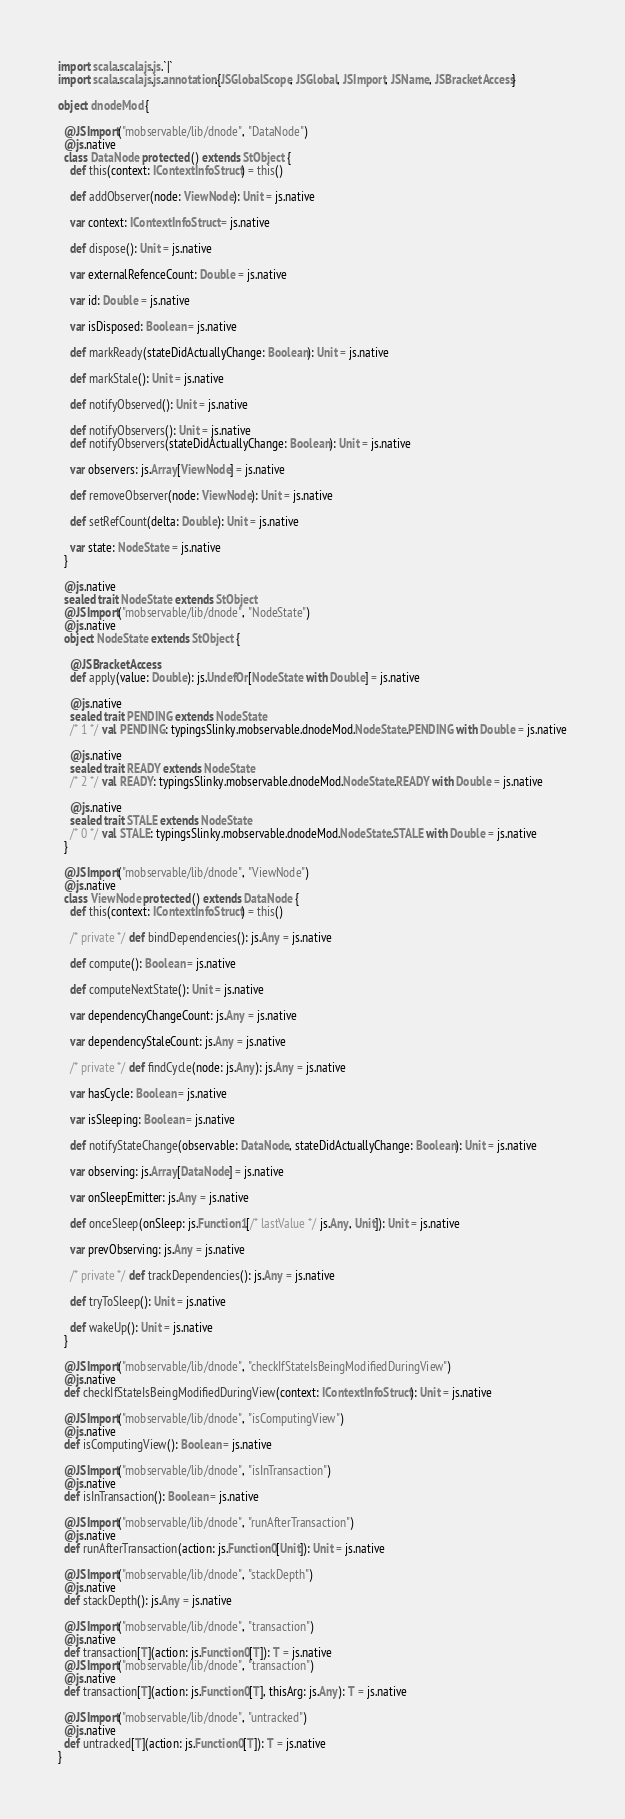Convert code to text. <code><loc_0><loc_0><loc_500><loc_500><_Scala_>import scala.scalajs.js.`|`
import scala.scalajs.js.annotation.{JSGlobalScope, JSGlobal, JSImport, JSName, JSBracketAccess}

object dnodeMod {
  
  @JSImport("mobservable/lib/dnode", "DataNode")
  @js.native
  class DataNode protected () extends StObject {
    def this(context: IContextInfoStruct) = this()
    
    def addObserver(node: ViewNode): Unit = js.native
    
    var context: IContextInfoStruct = js.native
    
    def dispose(): Unit = js.native
    
    var externalRefenceCount: Double = js.native
    
    var id: Double = js.native
    
    var isDisposed: Boolean = js.native
    
    def markReady(stateDidActuallyChange: Boolean): Unit = js.native
    
    def markStale(): Unit = js.native
    
    def notifyObserved(): Unit = js.native
    
    def notifyObservers(): Unit = js.native
    def notifyObservers(stateDidActuallyChange: Boolean): Unit = js.native
    
    var observers: js.Array[ViewNode] = js.native
    
    def removeObserver(node: ViewNode): Unit = js.native
    
    def setRefCount(delta: Double): Unit = js.native
    
    var state: NodeState = js.native
  }
  
  @js.native
  sealed trait NodeState extends StObject
  @JSImport("mobservable/lib/dnode", "NodeState")
  @js.native
  object NodeState extends StObject {
    
    @JSBracketAccess
    def apply(value: Double): js.UndefOr[NodeState with Double] = js.native
    
    @js.native
    sealed trait PENDING extends NodeState
    /* 1 */ val PENDING: typingsSlinky.mobservable.dnodeMod.NodeState.PENDING with Double = js.native
    
    @js.native
    sealed trait READY extends NodeState
    /* 2 */ val READY: typingsSlinky.mobservable.dnodeMod.NodeState.READY with Double = js.native
    
    @js.native
    sealed trait STALE extends NodeState
    /* 0 */ val STALE: typingsSlinky.mobservable.dnodeMod.NodeState.STALE with Double = js.native
  }
  
  @JSImport("mobservable/lib/dnode", "ViewNode")
  @js.native
  class ViewNode protected () extends DataNode {
    def this(context: IContextInfoStruct) = this()
    
    /* private */ def bindDependencies(): js.Any = js.native
    
    def compute(): Boolean = js.native
    
    def computeNextState(): Unit = js.native
    
    var dependencyChangeCount: js.Any = js.native
    
    var dependencyStaleCount: js.Any = js.native
    
    /* private */ def findCycle(node: js.Any): js.Any = js.native
    
    var hasCycle: Boolean = js.native
    
    var isSleeping: Boolean = js.native
    
    def notifyStateChange(observable: DataNode, stateDidActuallyChange: Boolean): Unit = js.native
    
    var observing: js.Array[DataNode] = js.native
    
    var onSleepEmitter: js.Any = js.native
    
    def onceSleep(onSleep: js.Function1[/* lastValue */ js.Any, Unit]): Unit = js.native
    
    var prevObserving: js.Any = js.native
    
    /* private */ def trackDependencies(): js.Any = js.native
    
    def tryToSleep(): Unit = js.native
    
    def wakeUp(): Unit = js.native
  }
  
  @JSImport("mobservable/lib/dnode", "checkIfStateIsBeingModifiedDuringView")
  @js.native
  def checkIfStateIsBeingModifiedDuringView(context: IContextInfoStruct): Unit = js.native
  
  @JSImport("mobservable/lib/dnode", "isComputingView")
  @js.native
  def isComputingView(): Boolean = js.native
  
  @JSImport("mobservable/lib/dnode", "isInTransaction")
  @js.native
  def isInTransaction(): Boolean = js.native
  
  @JSImport("mobservable/lib/dnode", "runAfterTransaction")
  @js.native
  def runAfterTransaction(action: js.Function0[Unit]): Unit = js.native
  
  @JSImport("mobservable/lib/dnode", "stackDepth")
  @js.native
  def stackDepth(): js.Any = js.native
  
  @JSImport("mobservable/lib/dnode", "transaction")
  @js.native
  def transaction[T](action: js.Function0[T]): T = js.native
  @JSImport("mobservable/lib/dnode", "transaction")
  @js.native
  def transaction[T](action: js.Function0[T], thisArg: js.Any): T = js.native
  
  @JSImport("mobservable/lib/dnode", "untracked")
  @js.native
  def untracked[T](action: js.Function0[T]): T = js.native
}
</code> 